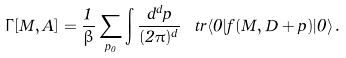<formula> <loc_0><loc_0><loc_500><loc_500>\Gamma [ M , A ] = \frac { 1 } { \beta } \sum _ { p _ { 0 } } \int \frac { d ^ { d } p } { ( 2 \pi ) ^ { d } } \, \ t r \langle 0 | f ( M , D + p ) | 0 \rangle \, .</formula> 